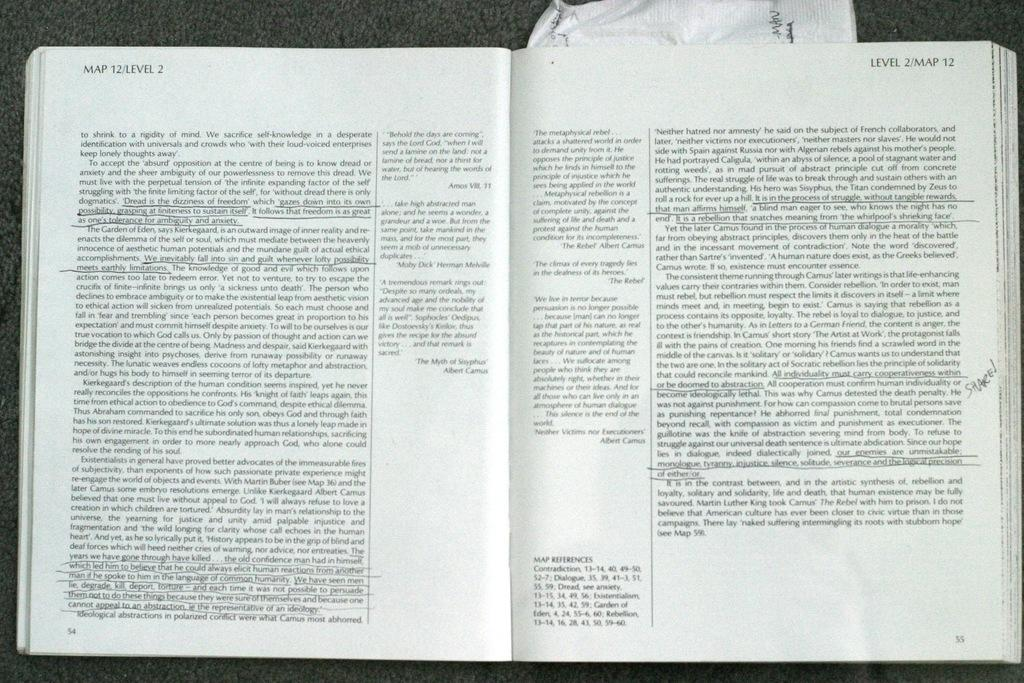<image>
Share a concise interpretation of the image provided. A book with underlined text is opened to Map 12 Level 2. 